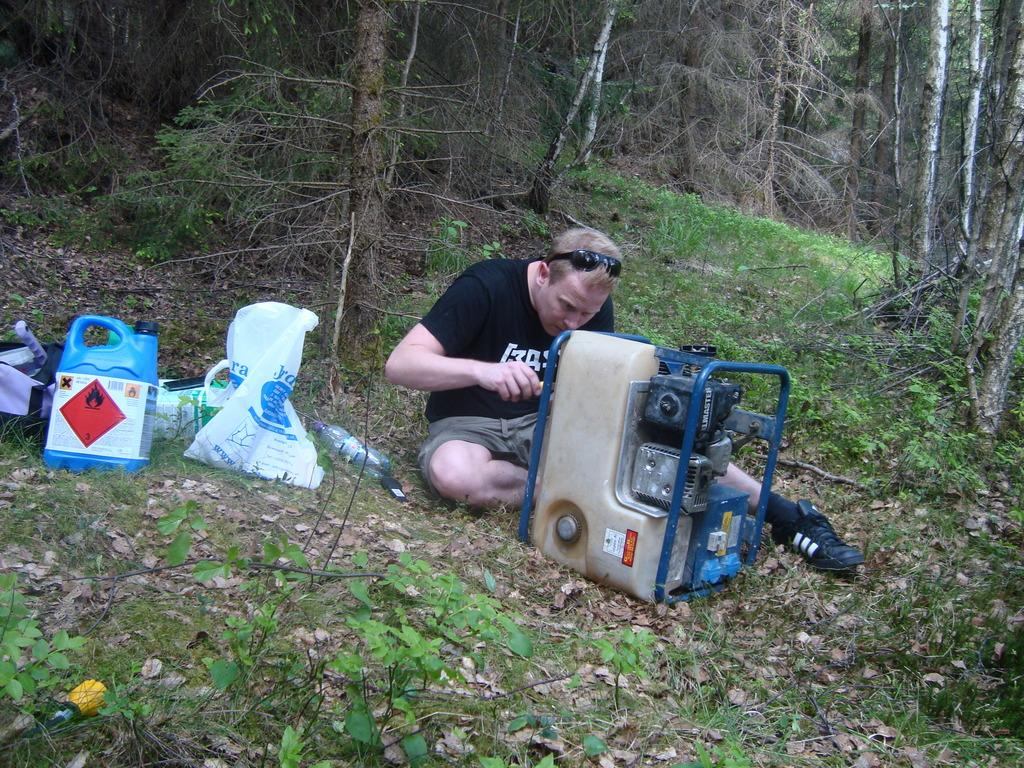What is the man in the image doing? The man is sitting and repairing a device in the image. What is covering the device that the man is repairing? There is a cover visible in the image. What type of objects can be seen in the image besides the device and cover? There is a bottle, a bag, and a can in the image. What can be seen in the background of the image? There are plants and tree trunks in the background of the image. What type of legal advice is the lawyer providing in the image? There is no lawyer present in the image, so it is not possible to answer that question. 